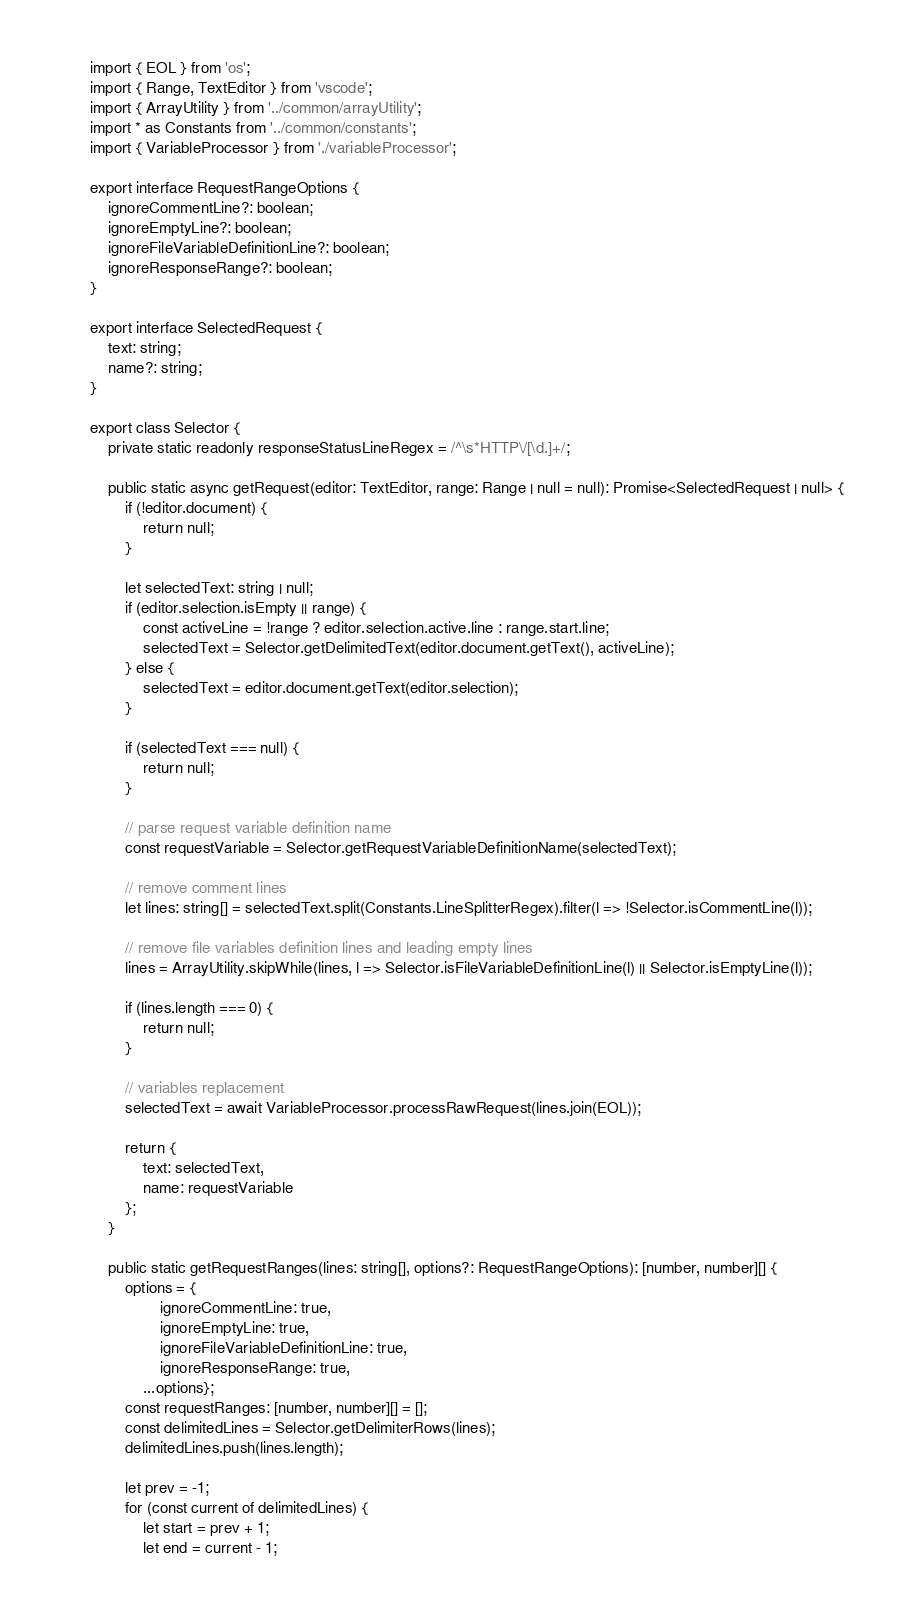<code> <loc_0><loc_0><loc_500><loc_500><_TypeScript_>import { EOL } from 'os';
import { Range, TextEditor } from 'vscode';
import { ArrayUtility } from '../common/arrayUtility';
import * as Constants from '../common/constants';
import { VariableProcessor } from './variableProcessor';

export interface RequestRangeOptions {
    ignoreCommentLine?: boolean;
    ignoreEmptyLine?: boolean;
    ignoreFileVariableDefinitionLine?: boolean;
    ignoreResponseRange?: boolean;
}

export interface SelectedRequest {
    text: string;
    name?: string;
}

export class Selector {
    private static readonly responseStatusLineRegex = /^\s*HTTP\/[\d.]+/;

    public static async getRequest(editor: TextEditor, range: Range | null = null): Promise<SelectedRequest | null> {
        if (!editor.document) {
            return null;
        }

        let selectedText: string | null;
        if (editor.selection.isEmpty || range) {
            const activeLine = !range ? editor.selection.active.line : range.start.line;
            selectedText = Selector.getDelimitedText(editor.document.getText(), activeLine);
        } else {
            selectedText = editor.document.getText(editor.selection);
        }

        if (selectedText === null) {
            return null;
        }

        // parse request variable definition name
        const requestVariable = Selector.getRequestVariableDefinitionName(selectedText);

        // remove comment lines
        let lines: string[] = selectedText.split(Constants.LineSplitterRegex).filter(l => !Selector.isCommentLine(l));

        // remove file variables definition lines and leading empty lines
        lines = ArrayUtility.skipWhile(lines, l => Selector.isFileVariableDefinitionLine(l) || Selector.isEmptyLine(l));

        if (lines.length === 0) {
            return null;
        }

        // variables replacement
        selectedText = await VariableProcessor.processRawRequest(lines.join(EOL));

        return {
            text: selectedText,
            name: requestVariable
        };
    }

    public static getRequestRanges(lines: string[], options?: RequestRangeOptions): [number, number][] {
        options = {
                ignoreCommentLine: true,
                ignoreEmptyLine: true,
                ignoreFileVariableDefinitionLine: true,
                ignoreResponseRange: true,
            ...options};
        const requestRanges: [number, number][] = [];
        const delimitedLines = Selector.getDelimiterRows(lines);
        delimitedLines.push(lines.length);

        let prev = -1;
        for (const current of delimitedLines) {
            let start = prev + 1;
            let end = current - 1;</code> 